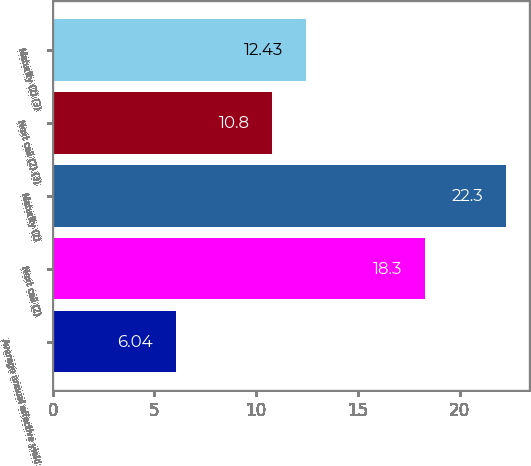Convert chart. <chart><loc_0><loc_0><loc_500><loc_500><bar_chart><fcel>Average annual effective yield<fcel>Next call (2)<fcel>Maturity (2)<fcel>Next call (2) (3)<fcel>Maturity (2) (3)<nl><fcel>6.04<fcel>18.3<fcel>22.3<fcel>10.8<fcel>12.43<nl></chart> 